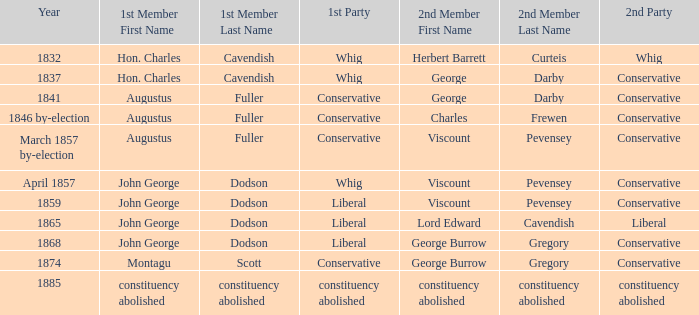In 1837, who was the 2nd member who's 2nd party was conservative. George Darby. 